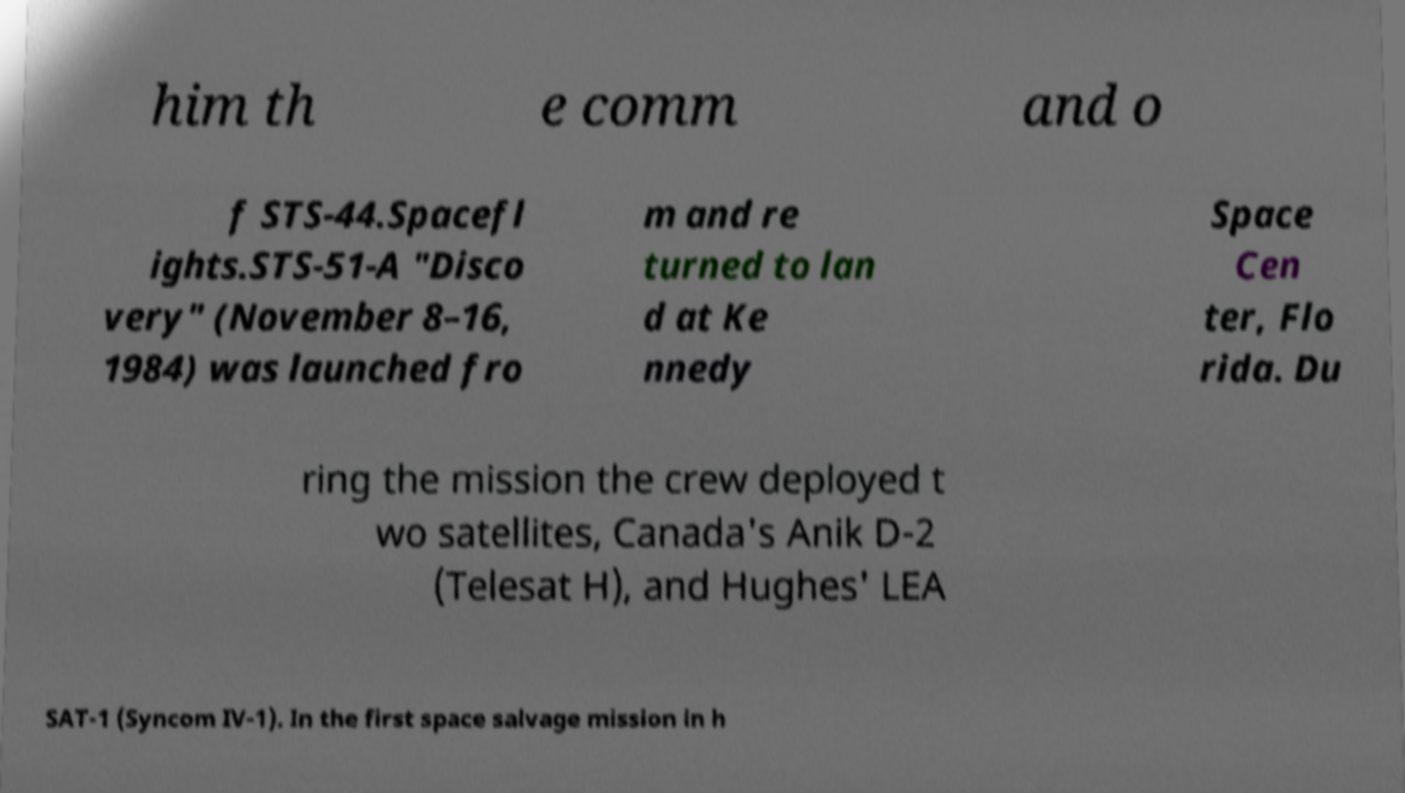Could you extract and type out the text from this image? him th e comm and o f STS-44.Spacefl ights.STS-51-A "Disco very" (November 8–16, 1984) was launched fro m and re turned to lan d at Ke nnedy Space Cen ter, Flo rida. Du ring the mission the crew deployed t wo satellites, Canada's Anik D-2 (Telesat H), and Hughes' LEA SAT-1 (Syncom IV-1). In the first space salvage mission in h 